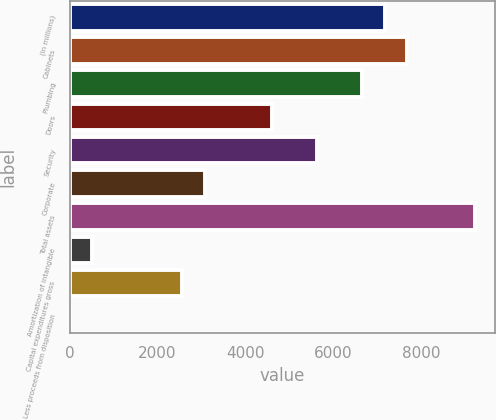<chart> <loc_0><loc_0><loc_500><loc_500><bar_chart><fcel>(In millions)<fcel>Cabinets<fcel>Plumbing<fcel>Doors<fcel>Security<fcel>Corporate<fcel>Total assets<fcel>Amortization of intangible<fcel>Capital expenditures gross<fcel>Less proceeds from disposition<nl><fcel>7178.34<fcel>7690.8<fcel>6665.88<fcel>4616.04<fcel>5640.96<fcel>3078.66<fcel>9228.18<fcel>516.36<fcel>2566.2<fcel>3.9<nl></chart> 